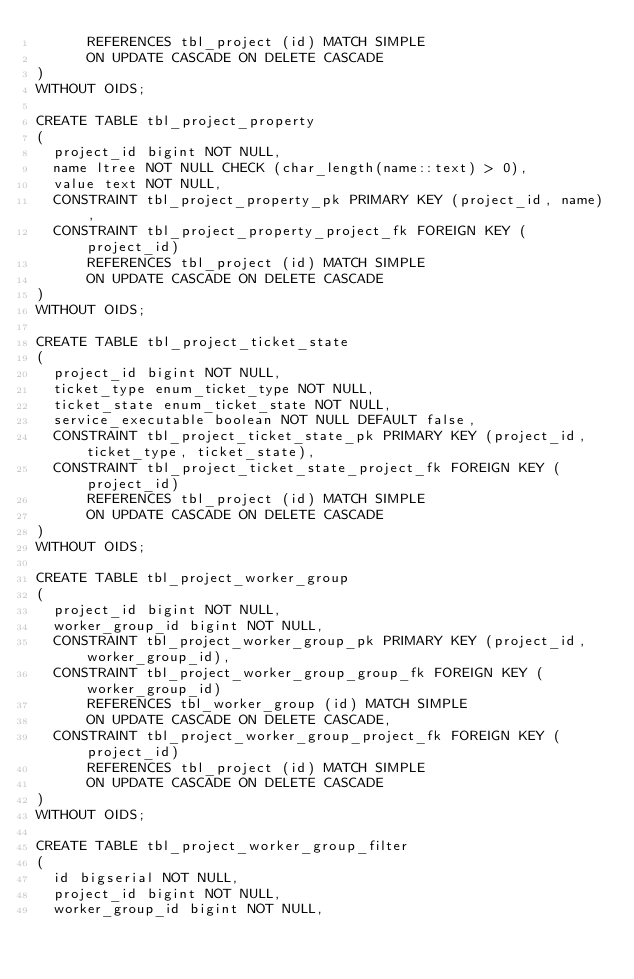Convert code to text. <code><loc_0><loc_0><loc_500><loc_500><_SQL_>      REFERENCES tbl_project (id) MATCH SIMPLE
      ON UPDATE CASCADE ON DELETE CASCADE
)
WITHOUT OIDS;

CREATE TABLE tbl_project_property
(
  project_id bigint NOT NULL,
  name ltree NOT NULL CHECK (char_length(name::text) > 0),
  value text NOT NULL,
  CONSTRAINT tbl_project_property_pk PRIMARY KEY (project_id, name),
  CONSTRAINT tbl_project_property_project_fk FOREIGN KEY (project_id)
      REFERENCES tbl_project (id) MATCH SIMPLE
      ON UPDATE CASCADE ON DELETE CASCADE
)
WITHOUT OIDS;

CREATE TABLE tbl_project_ticket_state
(
  project_id bigint NOT NULL,
  ticket_type enum_ticket_type NOT NULL,
  ticket_state enum_ticket_state NOT NULL,
  service_executable boolean NOT NULL DEFAULT false,
  CONSTRAINT tbl_project_ticket_state_pk PRIMARY KEY (project_id, ticket_type, ticket_state),
  CONSTRAINT tbl_project_ticket_state_project_fk FOREIGN KEY (project_id)
      REFERENCES tbl_project (id) MATCH SIMPLE
      ON UPDATE CASCADE ON DELETE CASCADE
)
WITHOUT OIDS;

CREATE TABLE tbl_project_worker_group
(
  project_id bigint NOT NULL,
  worker_group_id bigint NOT NULL,
  CONSTRAINT tbl_project_worker_group_pk PRIMARY KEY (project_id, worker_group_id),
  CONSTRAINT tbl_project_worker_group_group_fk FOREIGN KEY (worker_group_id)
      REFERENCES tbl_worker_group (id) MATCH SIMPLE
      ON UPDATE CASCADE ON DELETE CASCADE,
  CONSTRAINT tbl_project_worker_group_project_fk FOREIGN KEY (project_id)
      REFERENCES tbl_project (id) MATCH SIMPLE
      ON UPDATE CASCADE ON DELETE CASCADE
)
WITHOUT OIDS;

CREATE TABLE tbl_project_worker_group_filter
(
  id bigserial NOT NULL,
  project_id bigint NOT NULL,
  worker_group_id bigint NOT NULL,</code> 